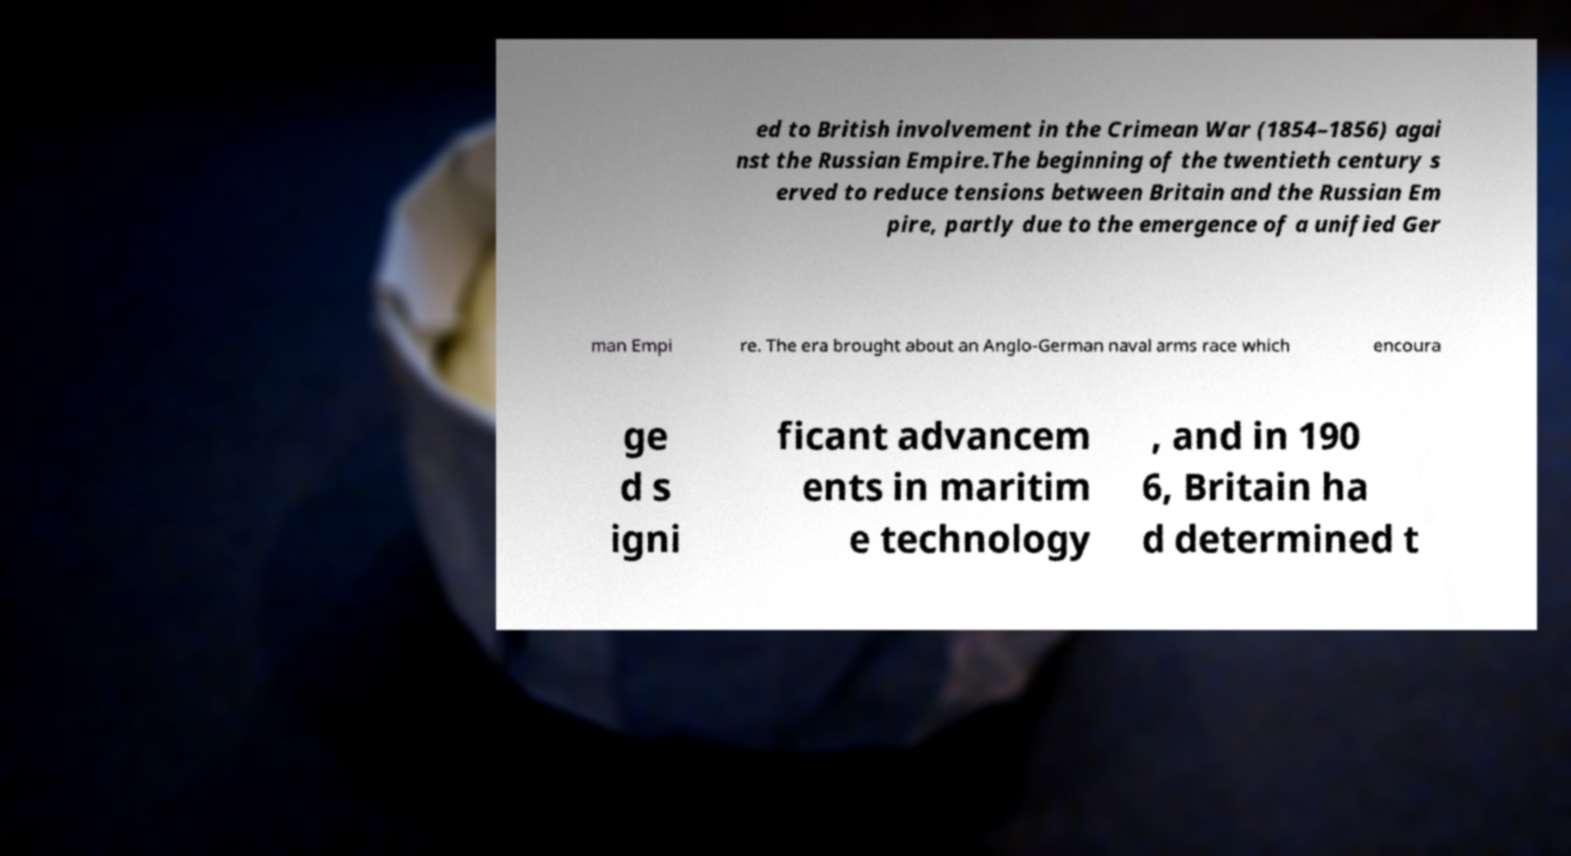Please identify and transcribe the text found in this image. ed to British involvement in the Crimean War (1854–1856) agai nst the Russian Empire.The beginning of the twentieth century s erved to reduce tensions between Britain and the Russian Em pire, partly due to the emergence of a unified Ger man Empi re. The era brought about an Anglo-German naval arms race which encoura ge d s igni ficant advancem ents in maritim e technology , and in 190 6, Britain ha d determined t 